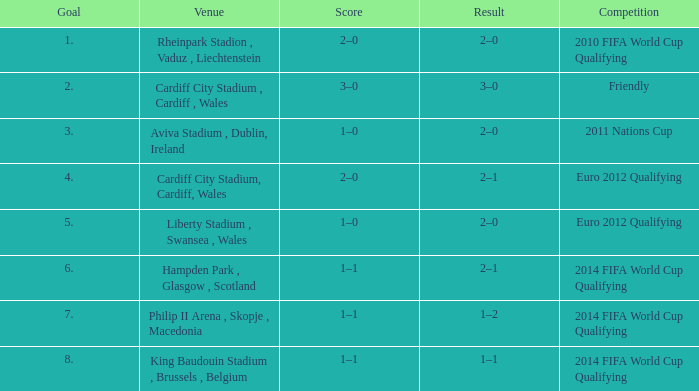What is the Venue for Goal number 1? Rheinpark Stadion , Vaduz , Liechtenstein. 